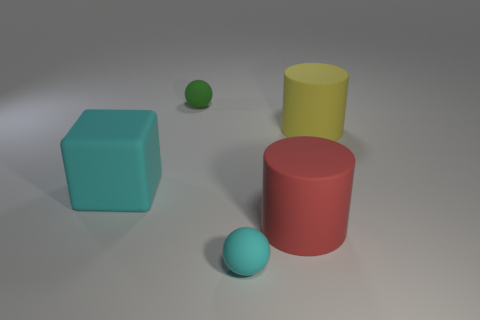What number of tiny things are either balls or yellow things?
Ensure brevity in your answer.  2. There is a object that is right of the tiny green rubber ball and behind the big red rubber cylinder; what color is it?
Make the answer very short. Yellow. Are there any other yellow objects that have the same shape as the big yellow thing?
Your answer should be very brief. No. What is the yellow cylinder made of?
Give a very brief answer. Rubber. Are there any big red rubber objects right of the big yellow thing?
Provide a succinct answer. No. Do the small green rubber object and the tiny cyan matte thing have the same shape?
Provide a short and direct response. Yes. How many other objects are there of the same size as the red cylinder?
Your answer should be very brief. 2. How many objects are small things that are in front of the yellow matte cylinder or objects?
Your answer should be very brief. 5. The matte block is what color?
Provide a succinct answer. Cyan. Does the big red object have the same shape as the large matte thing that is behind the cyan rubber block?
Make the answer very short. Yes. 